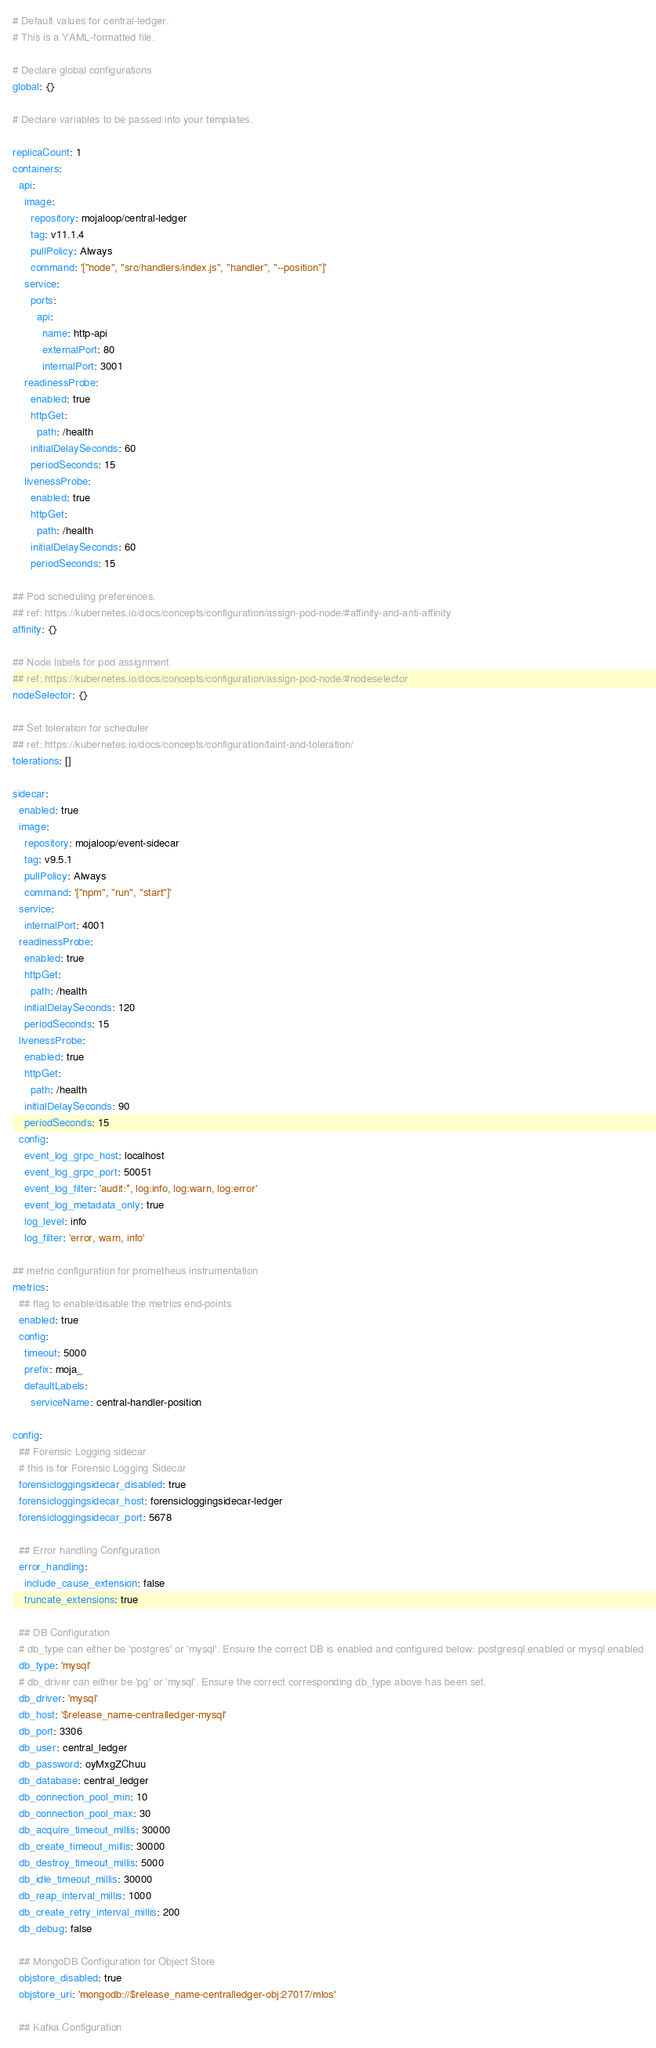<code> <loc_0><loc_0><loc_500><loc_500><_YAML_># Default values for central-ledger.
# This is a YAML-formatted file.

# Declare global configurations
global: {}

# Declare variables to be passed into your templates.

replicaCount: 1
containers:
  api:
    image:
      repository: mojaloop/central-ledger
      tag: v11.1.4
      pullPolicy: Always
      command: '["node", "src/handlers/index.js", "handler", "--position"]'
    service:
      ports:
        api:
          name: http-api
          externalPort: 80
          internalPort: 3001
    readinessProbe:
      enabled: true
      httpGet:
        path: /health
      initialDelaySeconds: 60
      periodSeconds: 15
    livenessProbe:
      enabled: true
      httpGet:
        path: /health
      initialDelaySeconds: 60
      periodSeconds: 15

## Pod scheduling preferences.
## ref: https://kubernetes.io/docs/concepts/configuration/assign-pod-node/#affinity-and-anti-affinity
affinity: {}

## Node labels for pod assignment
## ref: https://kubernetes.io/docs/concepts/configuration/assign-pod-node/#nodeselector
nodeSelector: {}

## Set toleration for scheduler
## ref: https://kubernetes.io/docs/concepts/configuration/taint-and-toleration/
tolerations: []

sidecar:
  enabled: true
  image:
    repository: mojaloop/event-sidecar
    tag: v9.5.1
    pullPolicy: Always
    command: '["npm", "run", "start"]'
  service:
    internalPort: 4001
  readinessProbe:
    enabled: true
    httpGet:
      path: /health
    initialDelaySeconds: 120
    periodSeconds: 15
  livenessProbe:
    enabled: true
    httpGet:
      path: /health
    initialDelaySeconds: 90
    periodSeconds: 15
  config:
    event_log_grpc_host: localhost
    event_log_grpc_port: 50051
    event_log_filter: 'audit:*, log:info, log:warn, log:error'
    event_log_metadata_only: true
    log_level: info
    log_filter: 'error, warn, info'

## metric configuration for prometheus instrumentation
metrics:
  ## flag to enable/disable the metrics end-points
  enabled: true
  config:
    timeout: 5000
    prefix: moja_
    defaultLabels:
      serviceName: central-handler-position

config:
  ## Forensic Logging sidecar
  # this is for Forensic Logging Sidecar
  forensicloggingsidecar_disabled: true
  forensicloggingsidecar_host: forensicloggingsidecar-ledger
  forensicloggingsidecar_port: 5678

  ## Error handling Configuration
  error_handling:
    include_cause_extension: false
    truncate_extensions: true

  ## DB Configuration
  # db_type can either be 'postgres' or 'mysql'. Ensure the correct DB is enabled and configured below: postgresql.enabled or mysql.enabled
  db_type: 'mysql'
  # db_driver can either be 'pg' or 'mysql'. Ensure the correct corresponding db_type above has been set.
  db_driver: 'mysql'
  db_host: '$release_name-centralledger-mysql'
  db_port: 3306
  db_user: central_ledger
  db_password: oyMxgZChuu
  db_database: central_ledger
  db_connection_pool_min: 10
  db_connection_pool_max: 30
  db_acquire_timeout_millis: 30000
  db_create_timeout_millis: 30000
  db_destroy_timeout_millis: 5000
  db_idle_timeout_millis: 30000
  db_reap_interval_millis: 1000
  db_create_retry_interval_millis: 200
  db_debug: false

  ## MongoDB Configuration for Object Store
  objstore_disabled: true
  objstore_uri: 'mongodb://$release_name-centralledger-obj:27017/mlos'

  ## Kafka Configuration</code> 